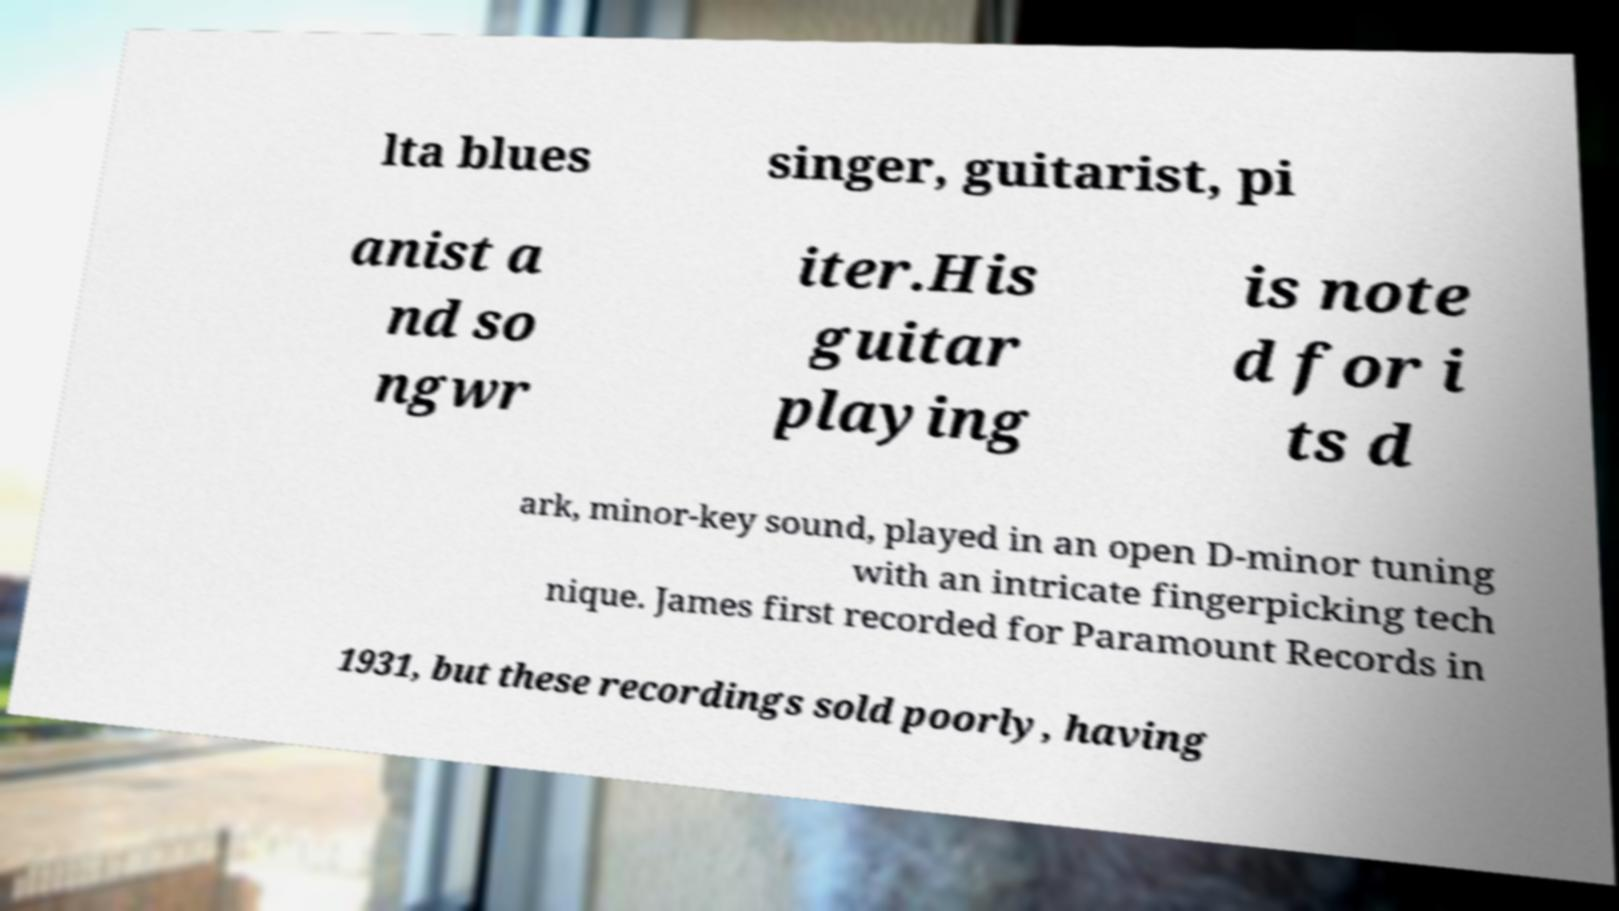Please identify and transcribe the text found in this image. lta blues singer, guitarist, pi anist a nd so ngwr iter.His guitar playing is note d for i ts d ark, minor-key sound, played in an open D-minor tuning with an intricate fingerpicking tech nique. James first recorded for Paramount Records in 1931, but these recordings sold poorly, having 